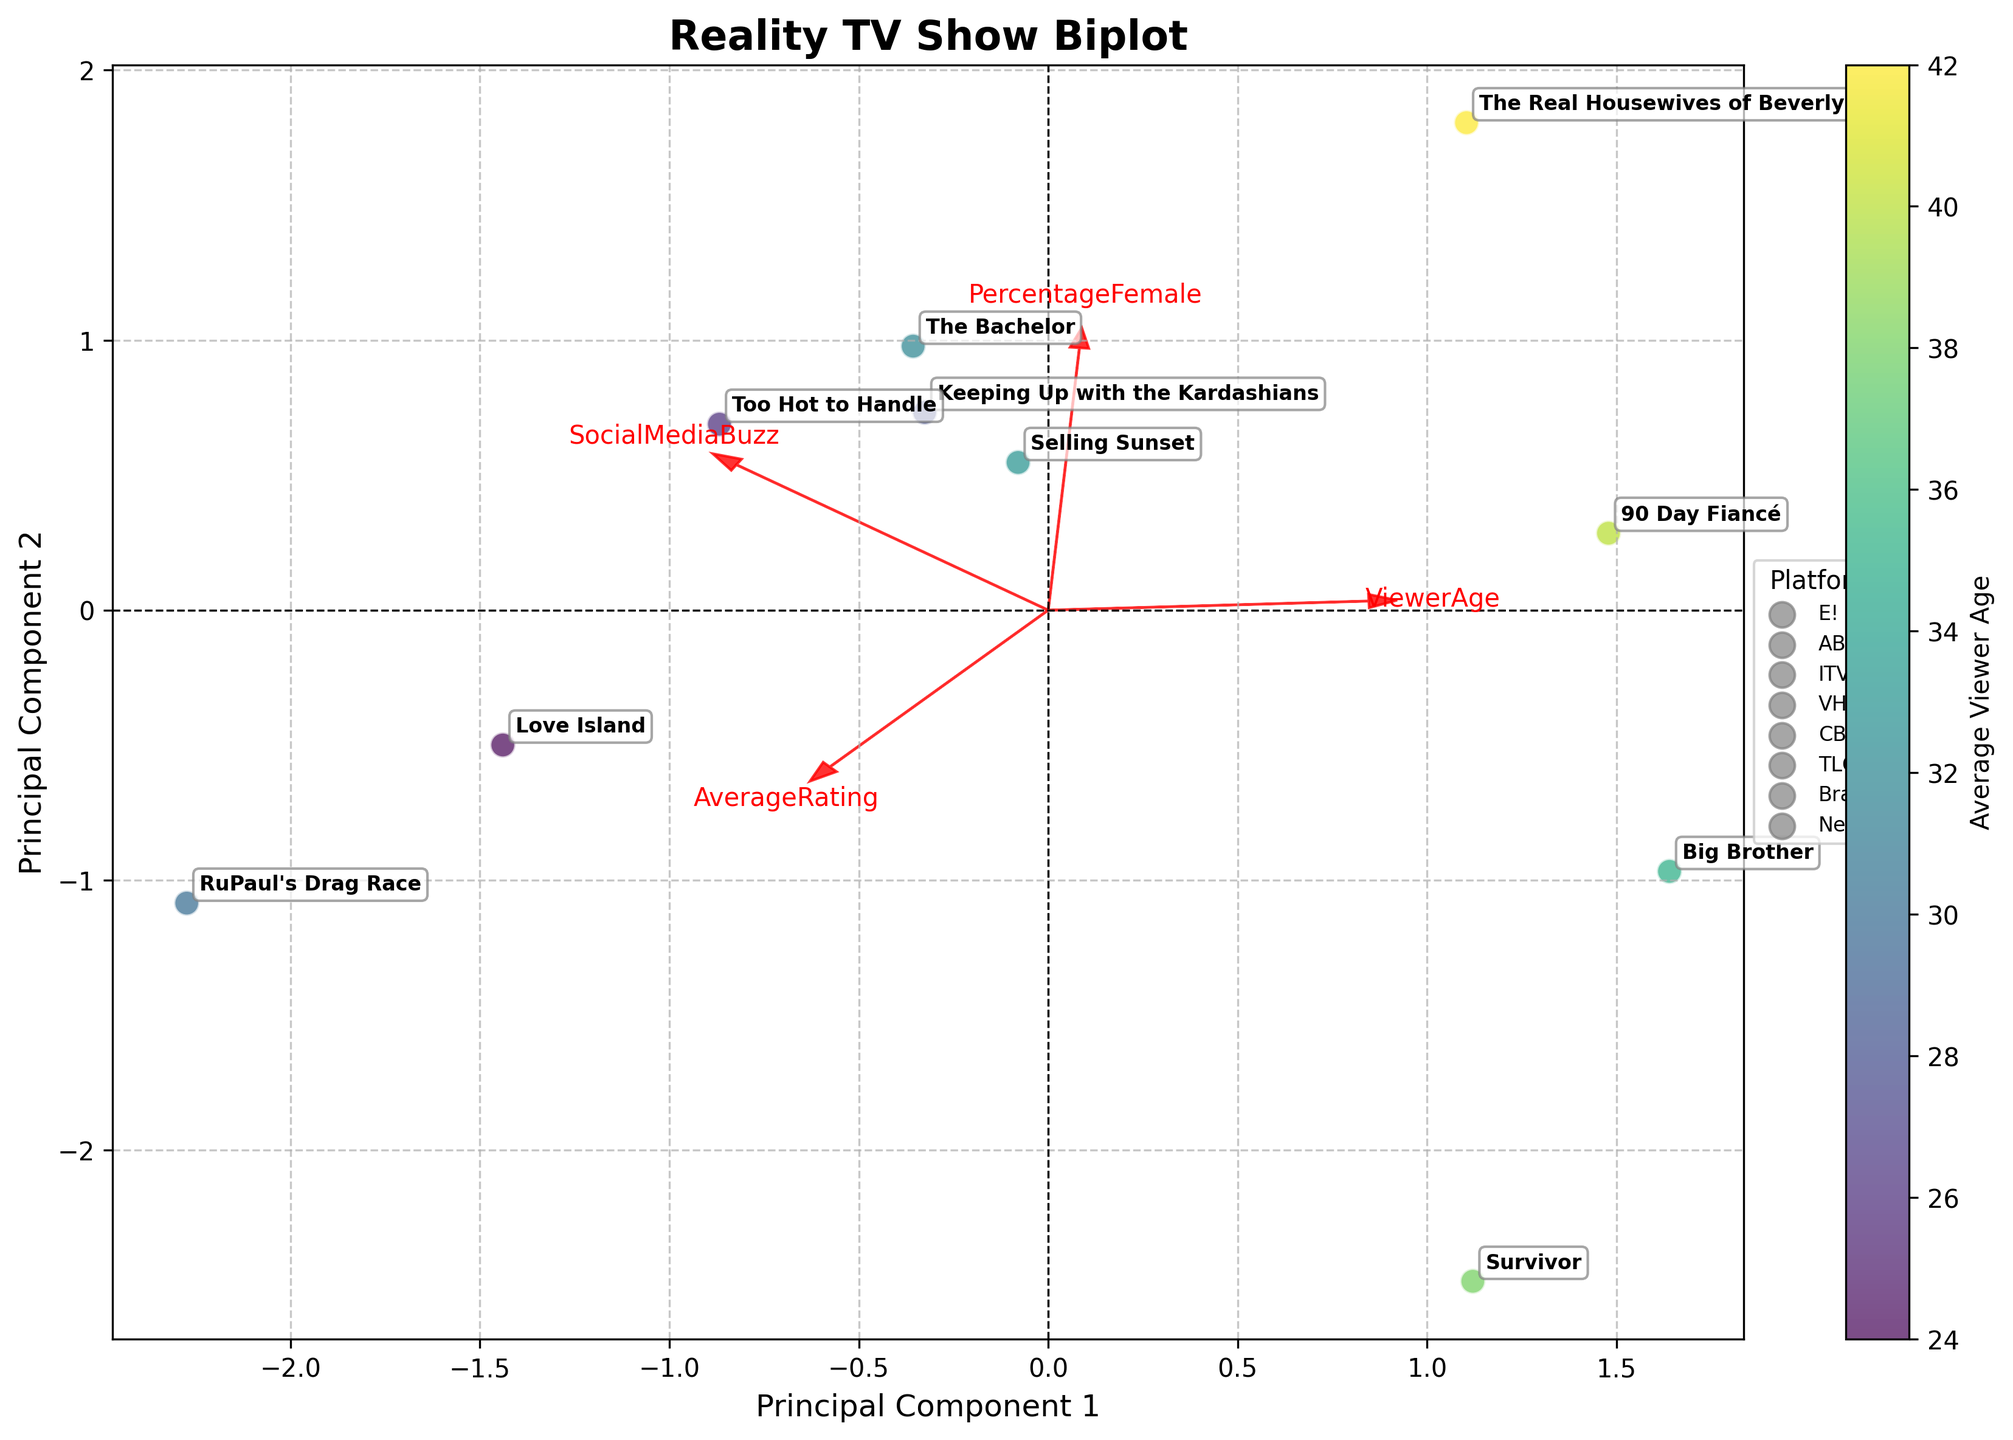What is the title of the biplot? The title is written at the top of the figure to indicate what the plot is about.
Answer: Reality TV Show Biplot How many shows have been plotted in the biplot? By counting the data points or the annotations for each show’s name on the biplot, we can determine the number of shows.
Answer: 10 Which show has the highest average rating? To find this, locate the annotated show names, then refer to the color scale or placement within the axes associated with high ratings.
Answer: RuPaul's Drag Race What feature does the colorbar represent? The color gradient shown alongside the plot indicates the feature represented by colors in the biplot.
Answer: Average Viewer Age Which platform has two shows plotted close together? By examining the annotated points and their labels, we can see which platform has two shows situated close to each other.
Answer: Netflix (Too Hot to Handle, Selling Sunset) What feature is indicated by the arrow pointing most rightwards? Arrows represent loadings for each feature, the arrow pointing most to the right indicates the feature strongly correlated with the positive direction of Principal Component 1.
Answer: PercentageFemale Compare the social media buzz of 'Keeping Up with the Kardashians' and 'Big Brother'. Which one is higher? Locate the positions of 'Keeping Up with the Kardashians' and 'Big Brother' and review the direction and magnitude of the SocialMediaBuzz loading vector for each.
Answer: Keeping Up with the Kardashians Considering the viewer age, which show seems to attract the youngest audience? Find the data points and colors representing viewer age in the color gradient. The youngest audience is shown by the point with the closest color to the lower end of the scale.
Answer: Love Island Which feature vector has the arrow pointing more vertically upwards and what does it suggest about the shows located in that direction? Identify the loading vectors and their directions to determine which one points more vertically. This suggests higher values for shows placed along the corresponding direction.
Answer: SocialMediaBuzz; Shows in that direction have higher social media buzz Between 'Survivor' and '90 Day Fiancé,' which has a larger female viewer percentage? Examine the positions correlating with the PercentageFemale feature arrow direction; the more aligned a show is with this vector, the higher its female viewer percentage.
Answer: The Real Housewives of Beverly Hills 